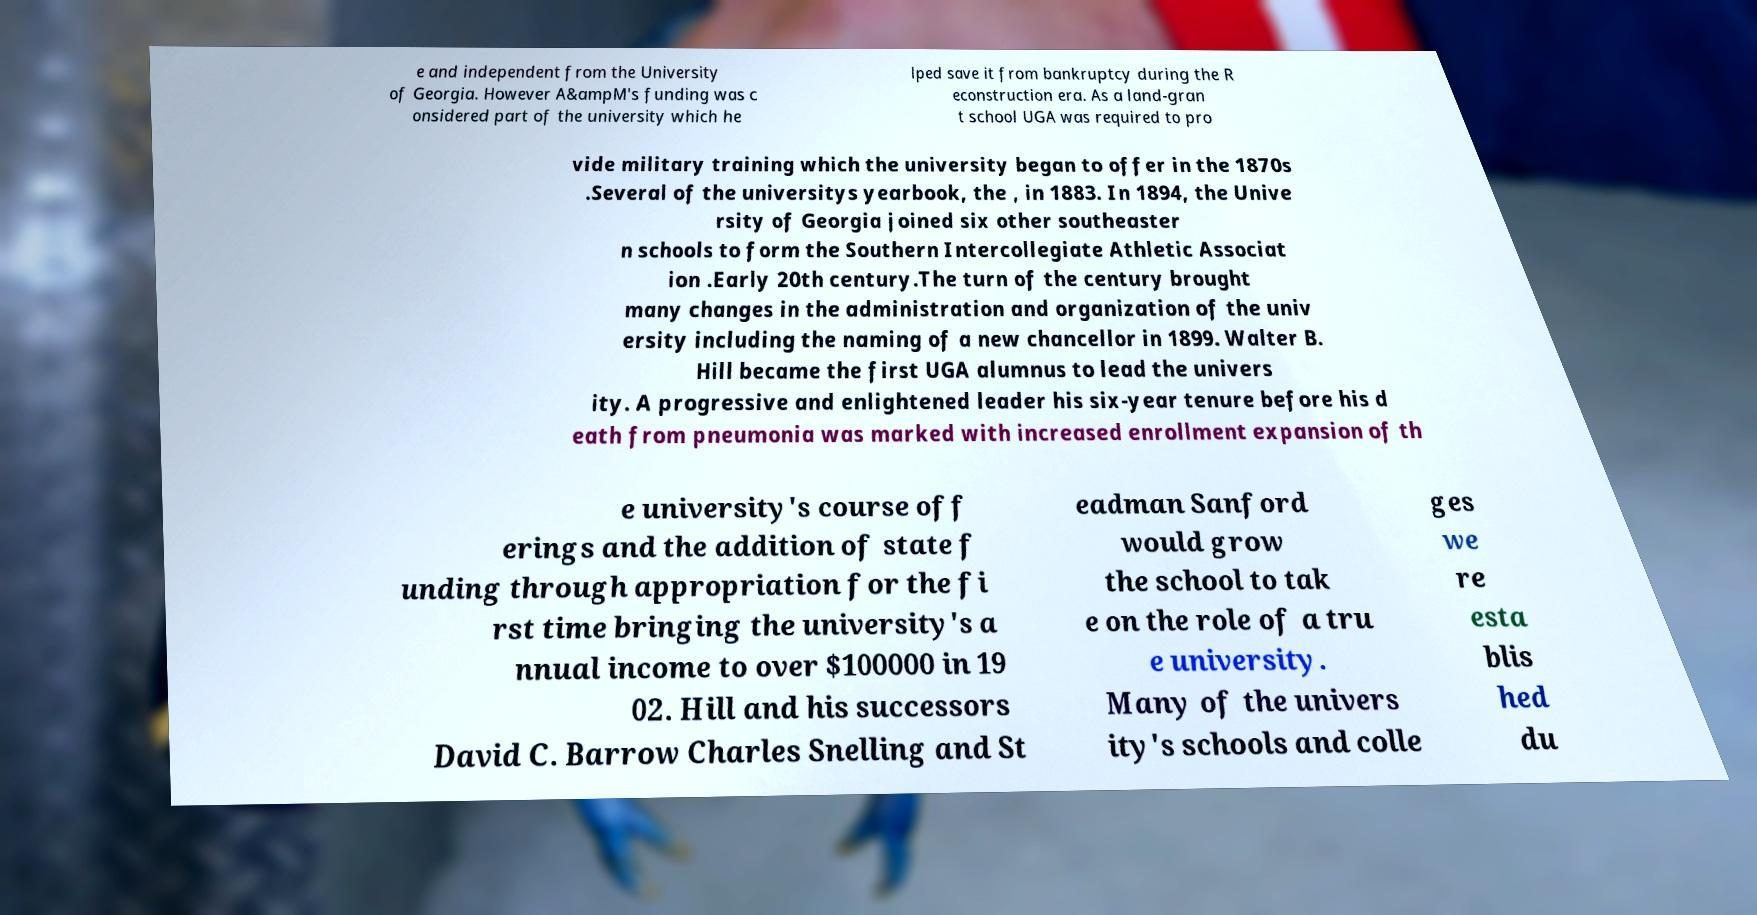Could you assist in decoding the text presented in this image and type it out clearly? e and independent from the University of Georgia. However A&ampM's funding was c onsidered part of the university which he lped save it from bankruptcy during the R econstruction era. As a land-gran t school UGA was required to pro vide military training which the university began to offer in the 1870s .Several of the universitys yearbook, the , in 1883. In 1894, the Unive rsity of Georgia joined six other southeaster n schools to form the Southern Intercollegiate Athletic Associat ion .Early 20th century.The turn of the century brought many changes in the administration and organization of the univ ersity including the naming of a new chancellor in 1899. Walter B. Hill became the first UGA alumnus to lead the univers ity. A progressive and enlightened leader his six-year tenure before his d eath from pneumonia was marked with increased enrollment expansion of th e university's course off erings and the addition of state f unding through appropriation for the fi rst time bringing the university's a nnual income to over $100000 in 19 02. Hill and his successors David C. Barrow Charles Snelling and St eadman Sanford would grow the school to tak e on the role of a tru e university. Many of the univers ity's schools and colle ges we re esta blis hed du 